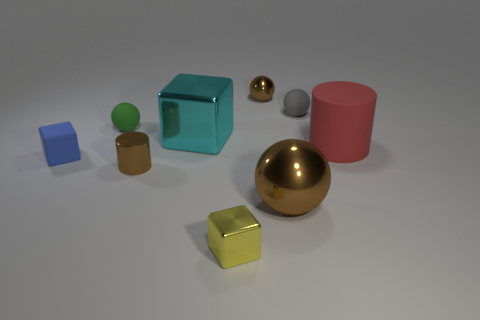Is the color of the tiny metallic object behind the tiny green sphere the same as the shiny cylinder?
Ensure brevity in your answer.  Yes. There is another rubber thing that is the same shape as the tiny gray matte thing; what size is it?
Your answer should be compact. Small. There is a metallic block behind the large brown shiny thing that is in front of the small brown metal object on the right side of the small yellow object; what color is it?
Provide a succinct answer. Cyan. Is the green thing made of the same material as the yellow block?
Your answer should be compact. No. There is a brown object that is to the right of the tiny brown metal thing that is right of the tiny yellow metallic cube; is there a small metallic object on the right side of it?
Your response must be concise. No. Do the small shiny sphere and the big metallic sphere have the same color?
Your answer should be very brief. Yes. Is the number of small matte spheres less than the number of large red matte cylinders?
Offer a terse response. No. Does the small brown object to the left of the tiny metal block have the same material as the cube to the left of the green sphere?
Your response must be concise. No. Are there fewer matte spheres behind the large brown object than metallic things?
Ensure brevity in your answer.  Yes. How many cyan objects are to the left of the tiny brown shiny thing that is in front of the red matte cylinder?
Your answer should be very brief. 0. 